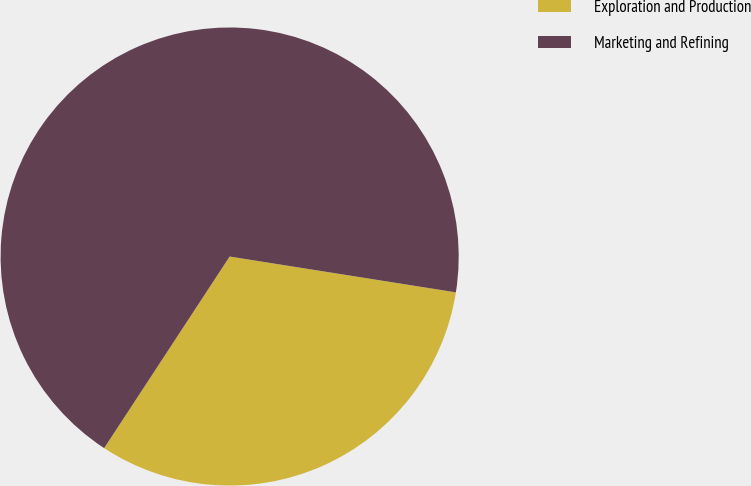Convert chart. <chart><loc_0><loc_0><loc_500><loc_500><pie_chart><fcel>Exploration and Production<fcel>Marketing and Refining<nl><fcel>31.73%<fcel>68.27%<nl></chart> 